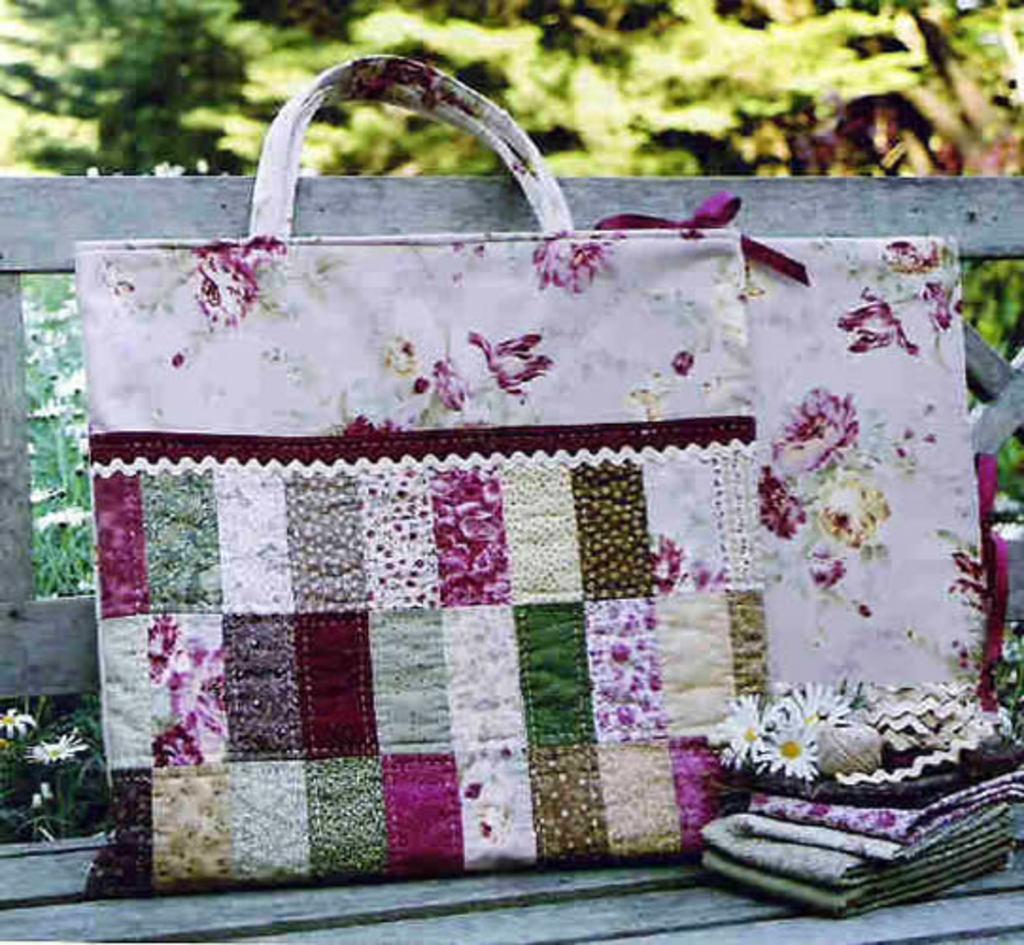Can you describe this image briefly? There is a bag in this picture placed on the bench here and a gift packing beside the bag. In the background there are some trees here. 